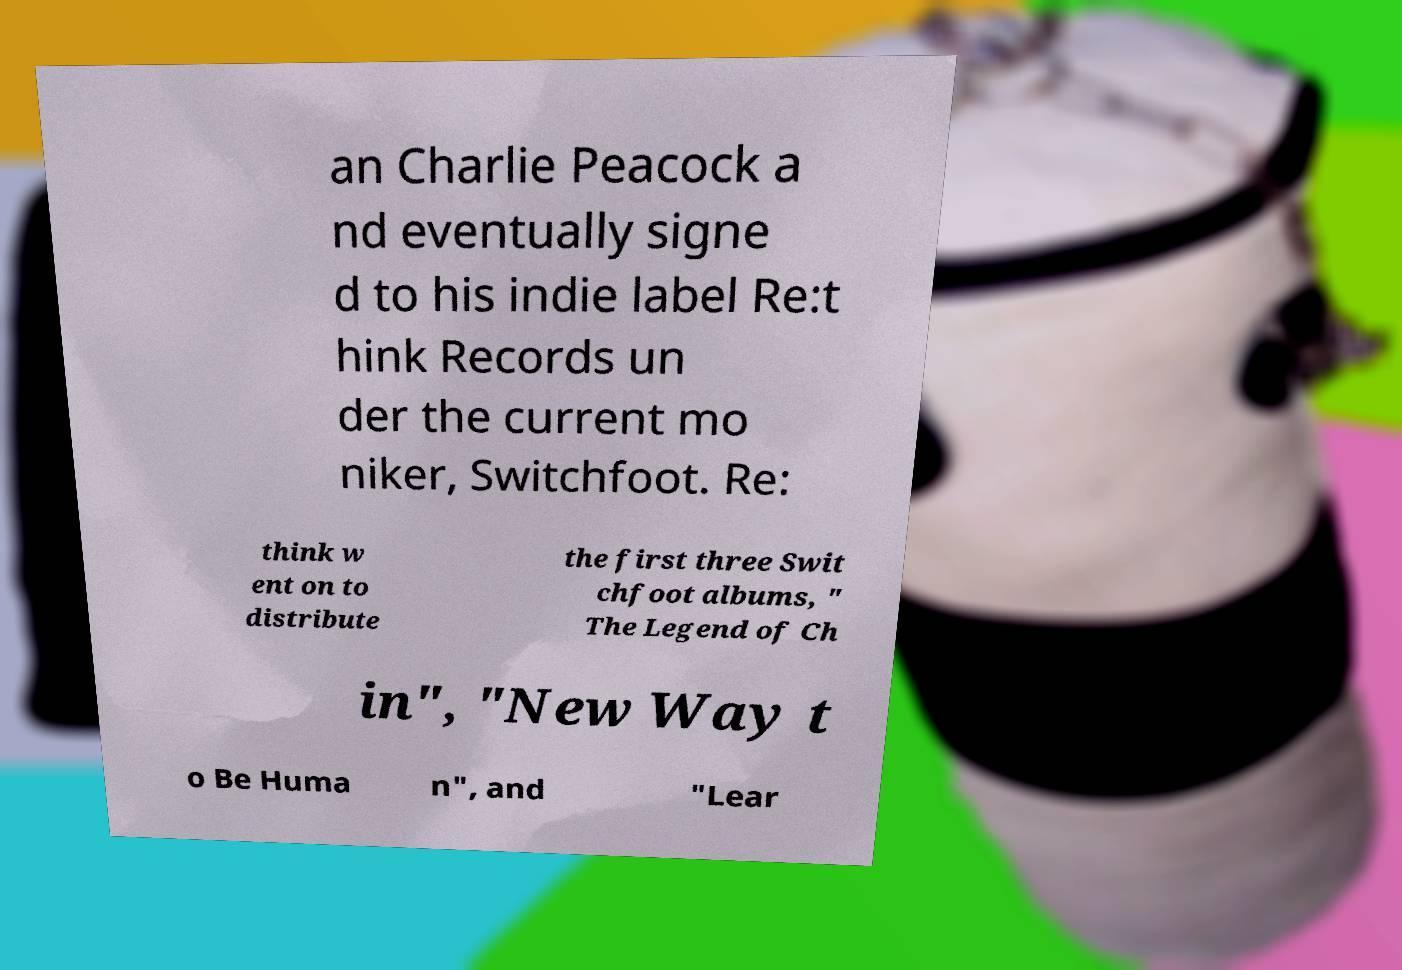Please identify and transcribe the text found in this image. an Charlie Peacock a nd eventually signe d to his indie label Re:t hink Records un der the current mo niker, Switchfoot. Re: think w ent on to distribute the first three Swit chfoot albums, " The Legend of Ch in", "New Way t o Be Huma n", and "Lear 